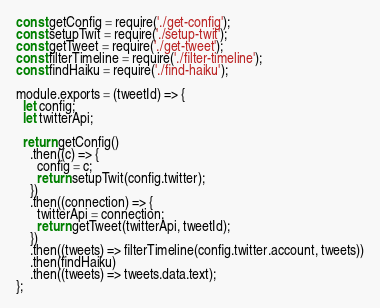<code> <loc_0><loc_0><loc_500><loc_500><_JavaScript_>const getConfig = require('./get-config');
const setupTwit = require('./setup-twit');
const getTweet = require('./get-tweet');
const filterTimeline = require('./filter-timeline');
const findHaiku = require('./find-haiku');

module.exports = (tweetId) => {
  let config;
  let twitterApi;

  return getConfig()
    .then((c) => {
      config = c;
      return setupTwit(config.twitter);
    })
    .then((connection) => {
      twitterApi = connection;
      return getTweet(twitterApi, tweetId);
    })
    .then((tweets) => filterTimeline(config.twitter.account, tweets))
    .then(findHaiku)
    .then((tweets) => tweets.data.text);
};
</code> 